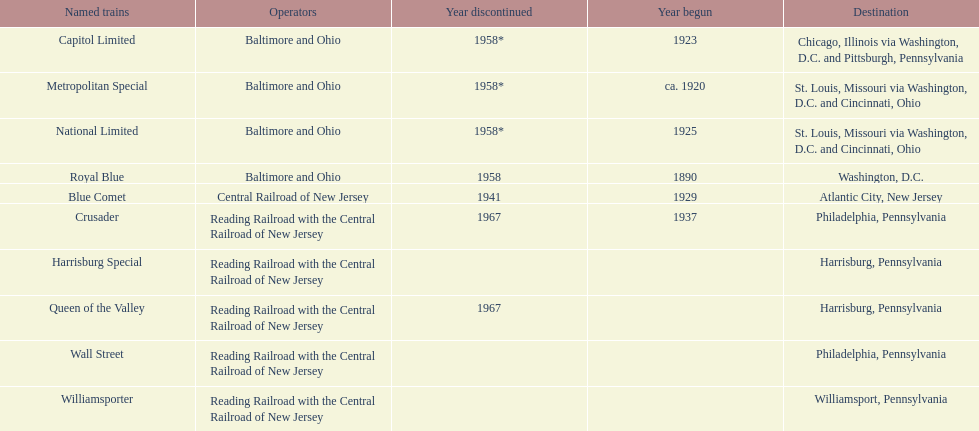How many trains were discontinued in 1958? 4. 